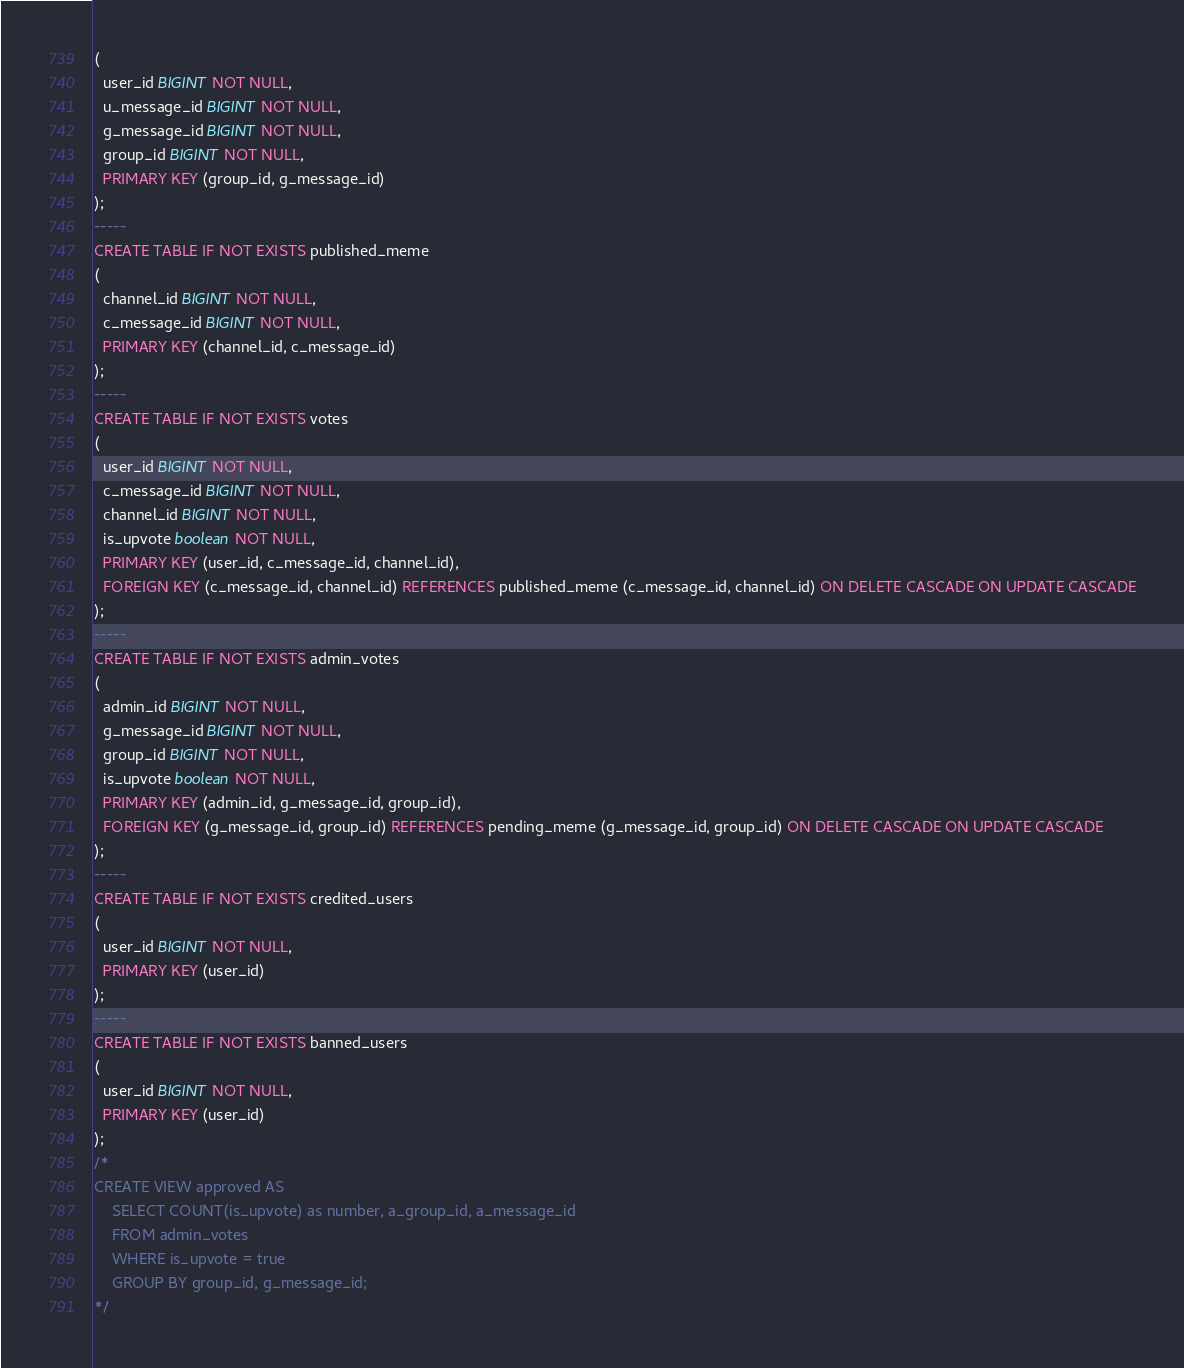<code> <loc_0><loc_0><loc_500><loc_500><_SQL_>(
  user_id BIGINT NOT NULL,
  u_message_id BIGINT NOT NULL,
  g_message_id BIGINT NOT NULL,
  group_id BIGINT NOT NULL,
  PRIMARY KEY (group_id, g_message_id)
);
-----
CREATE TABLE IF NOT EXISTS published_meme
(
  channel_id BIGINT NOT NULL,
  c_message_id BIGINT NOT NULL,
  PRIMARY KEY (channel_id, c_message_id)
);
-----
CREATE TABLE IF NOT EXISTS votes
(
  user_id BIGINT NOT NULL,
  c_message_id BIGINT NOT NULL,
  channel_id BIGINT NOT NULL,
  is_upvote boolean NOT NULL,
  PRIMARY KEY (user_id, c_message_id, channel_id),
  FOREIGN KEY (c_message_id, channel_id) REFERENCES published_meme (c_message_id, channel_id) ON DELETE CASCADE ON UPDATE CASCADE
);
-----
CREATE TABLE IF NOT EXISTS admin_votes
(
  admin_id BIGINT NOT NULL,
  g_message_id BIGINT NOT NULL,
  group_id BIGINT NOT NULL,
  is_upvote boolean NOT NULL,
  PRIMARY KEY (admin_id, g_message_id, group_id),
  FOREIGN KEY (g_message_id, group_id) REFERENCES pending_meme (g_message_id, group_id) ON DELETE CASCADE ON UPDATE CASCADE
);
-----
CREATE TABLE IF NOT EXISTS credited_users
(
  user_id BIGINT NOT NULL,
  PRIMARY KEY (user_id)
);
-----
CREATE TABLE IF NOT EXISTS banned_users
(
  user_id BIGINT NOT NULL,
  PRIMARY KEY (user_id)
);
/*
CREATE VIEW approved AS
    SELECT COUNT(is_upvote) as number, a_group_id, a_message_id 
    FROM admin_votes
    WHERE is_upvote = true
    GROUP BY group_id, g_message_id;
*/
</code> 